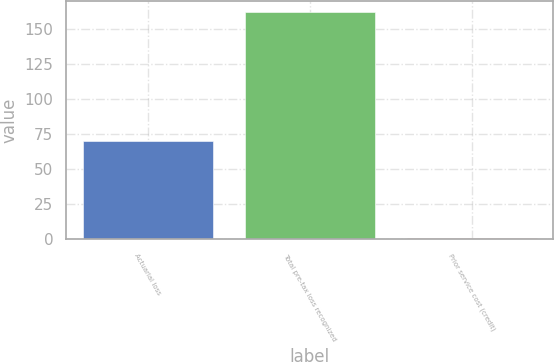<chart> <loc_0><loc_0><loc_500><loc_500><bar_chart><fcel>Actuarial loss<fcel>Total pre-tax loss recognized<fcel>Prior service cost (credit)<nl><fcel>70.1<fcel>162<fcel>1<nl></chart> 